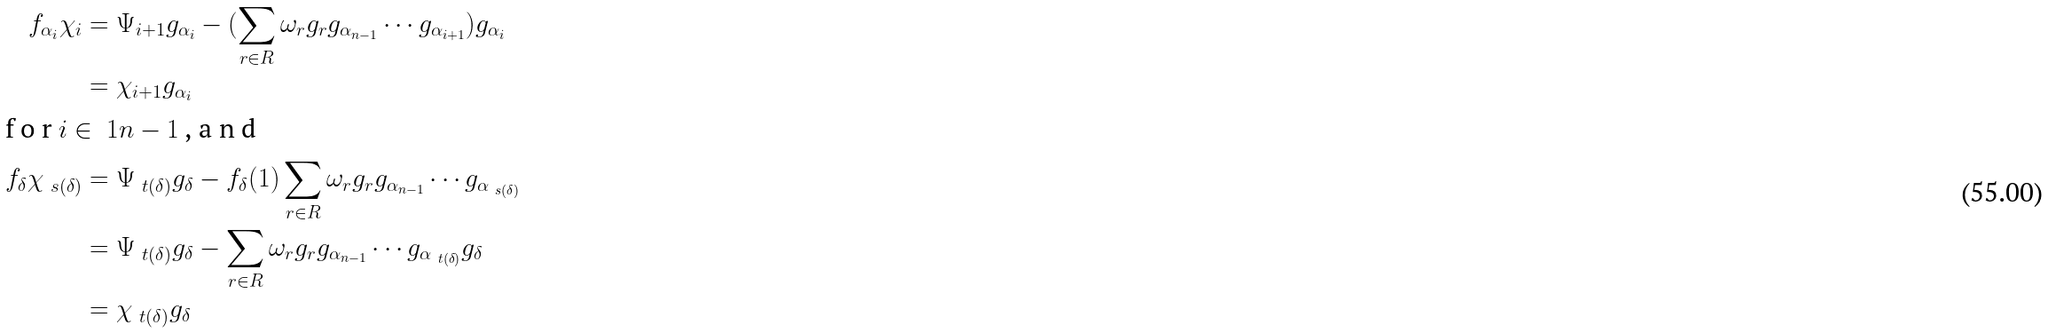Convert formula to latex. <formula><loc_0><loc_0><loc_500><loc_500>f _ { \alpha _ { i } } \chi _ { i } & = \Psi _ { i + 1 } g _ { \alpha _ { i } } - ( \sum _ { r \in R } \omega _ { r } g _ { r } g _ { \alpha _ { n - 1 } } \cdots g _ { \alpha _ { i + 1 } } ) g _ { \alpha _ { i } } \\ & = \chi _ { i + 1 } g _ { \alpha _ { i } } \\ \intertext { f o r $ i \in \ 1 { n - 1 } $ , a n d } f _ { \delta } \chi _ { \ s ( \delta ) } & = \Psi _ { \ t ( \delta ) } g _ { \delta } - f _ { \delta } ( 1 ) \sum _ { r \in R } \omega _ { r } g _ { r } g _ { \alpha _ { n - 1 } } \cdots g _ { \alpha _ { \ s ( \delta ) } } \\ & = \Psi _ { \ t ( \delta ) } g _ { \delta } - \sum _ { r \in R } \omega _ { r } g _ { r } g _ { \alpha _ { n - 1 } } \cdots g _ { \alpha _ { \ t ( \delta ) } } g _ { \delta } \\ & = \chi _ { \ t ( \delta ) } g _ { \delta }</formula> 